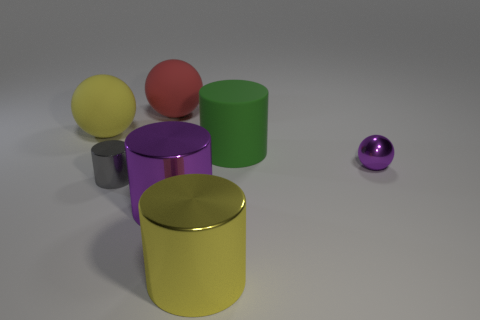What reflections can be observed on the surfaces of the objects? There are subtle reflections visible on the surfaces of the cylinders, indicative of a smooth but not overly reflective matte finish. The yellow and green cylinders reflect some light on their tops, while the magenta cylinder shows a gentle reflection of the environment on its side. The metallic purple ball has the most distinct reflection, mirroring the soft light and shapes of the other objects and environment around it. 